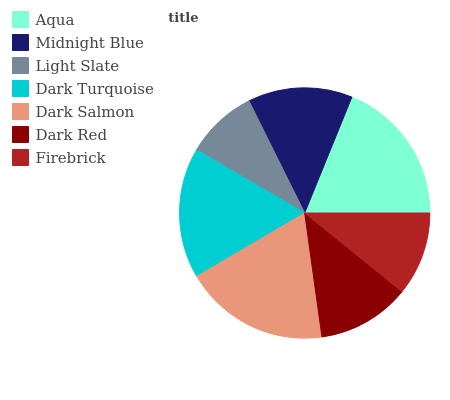Is Light Slate the minimum?
Answer yes or no. Yes. Is Aqua the maximum?
Answer yes or no. Yes. Is Midnight Blue the minimum?
Answer yes or no. No. Is Midnight Blue the maximum?
Answer yes or no. No. Is Aqua greater than Midnight Blue?
Answer yes or no. Yes. Is Midnight Blue less than Aqua?
Answer yes or no. Yes. Is Midnight Blue greater than Aqua?
Answer yes or no. No. Is Aqua less than Midnight Blue?
Answer yes or no. No. Is Midnight Blue the high median?
Answer yes or no. Yes. Is Midnight Blue the low median?
Answer yes or no. Yes. Is Dark Red the high median?
Answer yes or no. No. Is Dark Turquoise the low median?
Answer yes or no. No. 